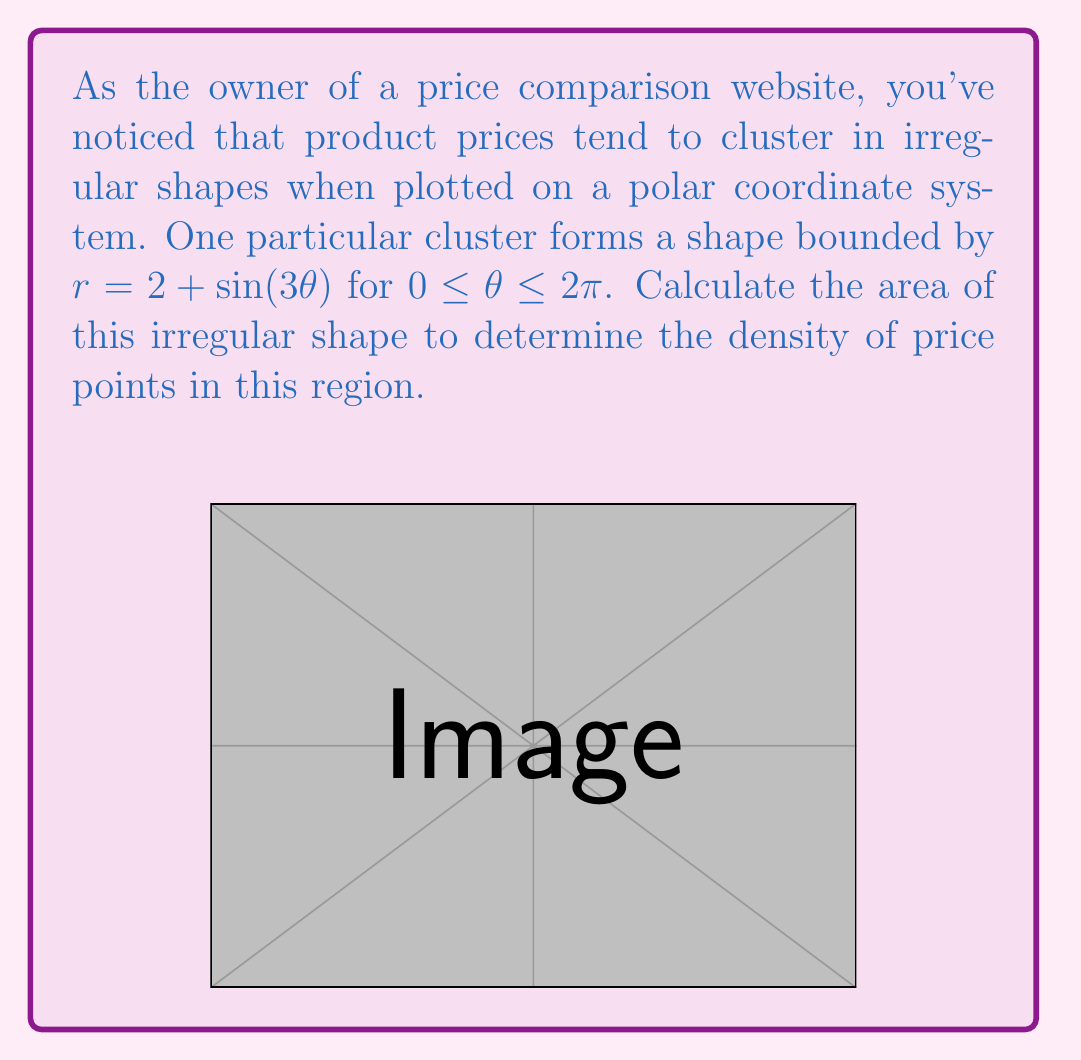Provide a solution to this math problem. To calculate the area of this irregular shape in polar coordinates, we need to use the formula:

$$ A = \frac{1}{2} \int_{0}^{2\pi} r^2(\theta) d\theta $$

Where $r(\theta) = 2 + \sin(3\theta)$

Let's break this down step-by-step:

1) First, we square the radius function:
   $$ r^2(\theta) = (2 + \sin(3\theta))^2 = 4 + 4\sin(3\theta) + \sin^2(3\theta) $$

2) Now we set up our integral:
   $$ A = \frac{1}{2} \int_{0}^{2\pi} (4 + 4\sin(3\theta) + \sin^2(3\theta)) d\theta $$

3) We can split this into three integrals:
   $$ A = \frac{1}{2} \left[ \int_{0}^{2\pi} 4 d\theta + \int_{0}^{2\pi} 4\sin(3\theta) d\theta + \int_{0}^{2\pi} \sin^2(3\theta) d\theta \right] $$

4) Let's solve each integral:
   - $\int_{0}^{2\pi} 4 d\theta = 4\theta \big|_{0}^{2\pi} = 8\pi$
   - $\int_{0}^{2\pi} 4\sin(3\theta) d\theta = -\frac{4}{3}\cos(3\theta) \big|_{0}^{2\pi} = 0$
   - For the last integral, we can use the identity $\sin^2(x) = \frac{1}{2}(1-\cos(2x))$:
     $\int_{0}^{2\pi} \sin^2(3\theta) d\theta = \int_{0}^{2\pi} \frac{1}{2}(1-\cos(6\theta)) d\theta$
     $= \frac{1}{2}\theta - \frac{1}{12}\sin(6\theta) \big|_{0}^{2\pi} = \pi$

5) Putting it all together:
   $$ A = \frac{1}{2} (8\pi + 0 + \pi) = \frac{9\pi}{2} $$

Thus, the area of the irregular shape is $\frac{9\pi}{2}$ square units.
Answer: $\frac{9\pi}{2}$ square units 